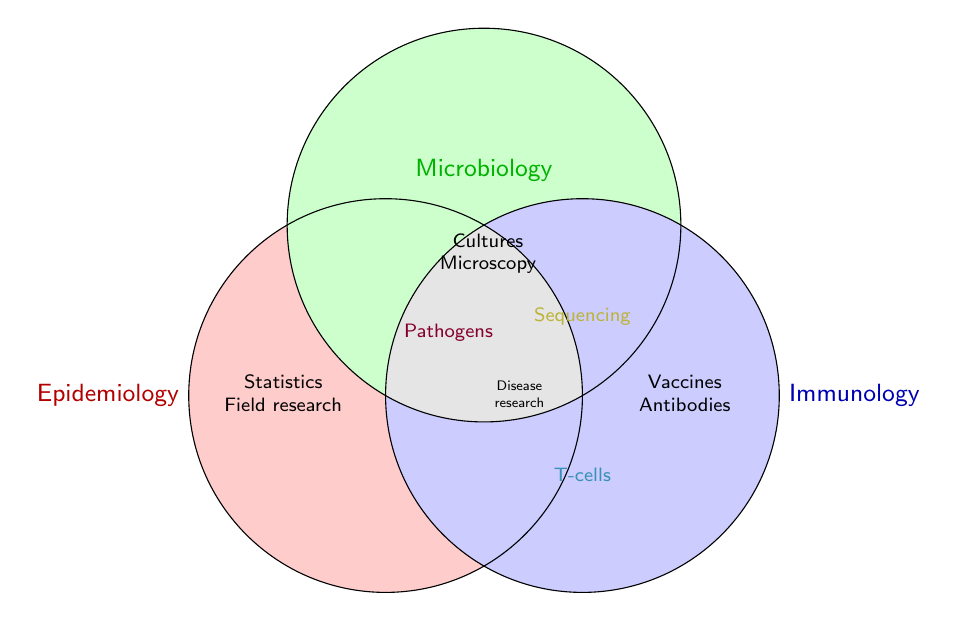What fields are represented in the figure? The figure represents three fields identified by their positioning and labels: Epidemiology, Microbiology, and Immunology.
Answer: Epidemiology, Microbiology, Immunology What does the red circle represent? The red circle corresponds to the field of Epidemiology.
Answer: Epidemiology Which field does the blue circle represent? The blue circle represents the field of Immunology.
Answer: Immunology Which field is associated with 'Microscopy'? 'Microscopy' is located in the green circle, which represents Microbiology.
Answer: Microbiology What is located at the intersection of all three circles? At the intersection of all three circles, labeled in gray, we find 'Disease research.'
Answer: Disease research How many activities are exclusive to Epidemiology? By referring to the red section, five activities are exclusive to Epidemiology: Disease outbreak investigation, Public health policy, Statistical analysis, Field research, and Surveillance systems.
Answer: Five Which activity is shared between Microbiology and Immunology but not Epidemiology? The figure shows 'Sequencing' in the overlapping area between Microbiology and Immunology (yellow section), excluding Epidemiology.
Answer: Sequencing What types of research are represented in the intersection of Epidemiology and Microbiology? The intersection of Epidemiology and Microbiology, displayed in purple, includes 'Pathogens.'
Answer: Pathogens What are the research activities listed exclusively under Immunology? 'Vaccines' and 'Antibodies' are exclusively listed under Immunology in the blue circle.
Answer: Vaccines, Antibodies 